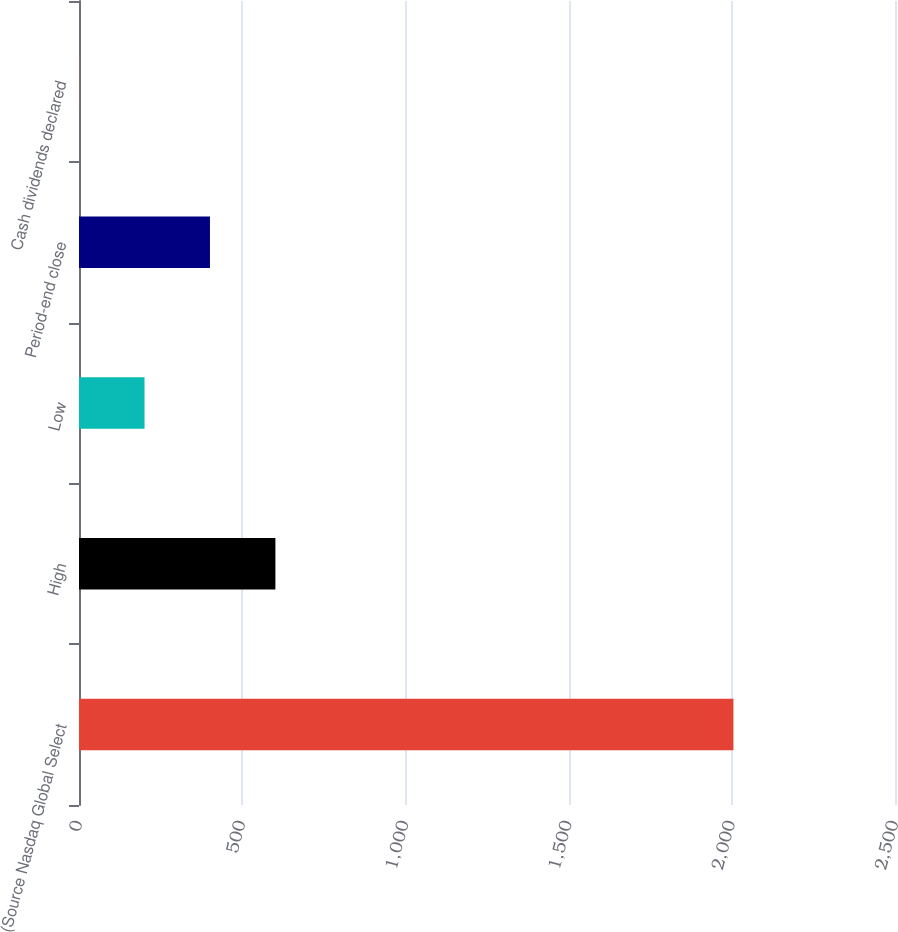<chart> <loc_0><loc_0><loc_500><loc_500><bar_chart><fcel>(Source Nasdaq Global Select<fcel>High<fcel>Low<fcel>Period-end close<fcel>Cash dividends declared<nl><fcel>2005<fcel>601.71<fcel>200.77<fcel>401.24<fcel>0.3<nl></chart> 